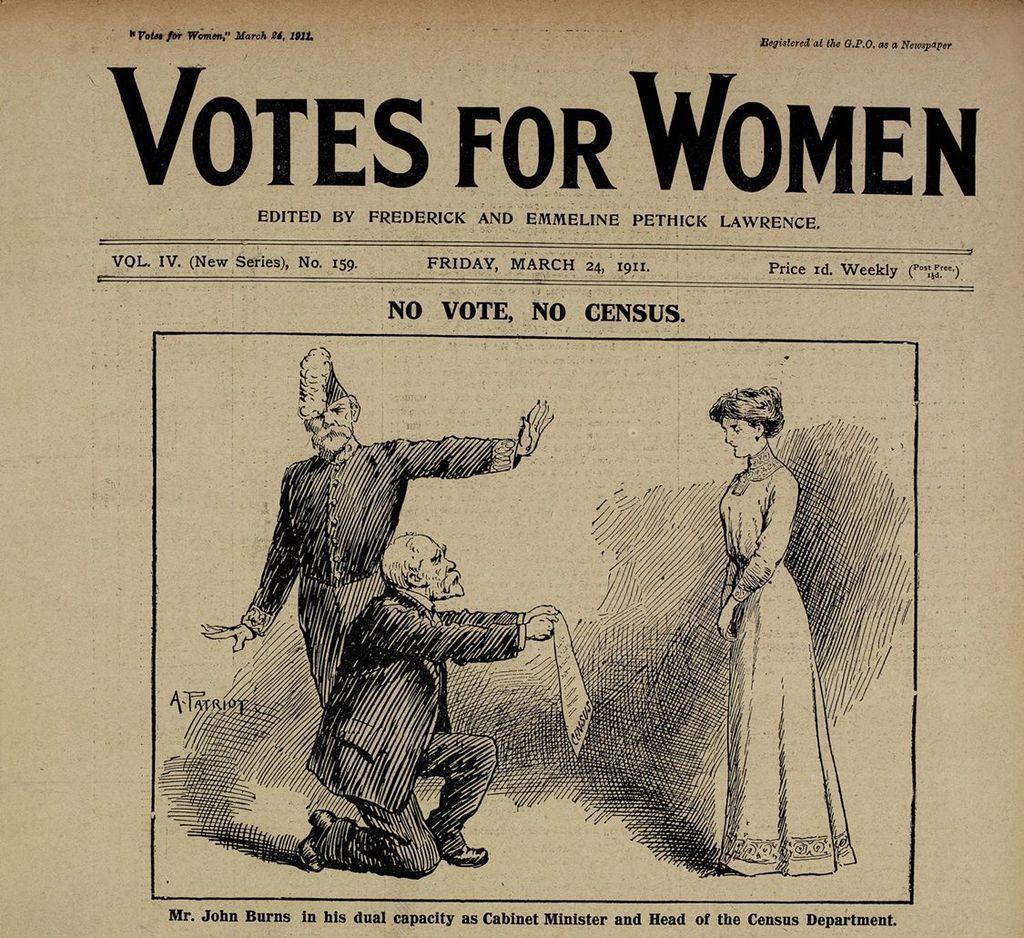Please provide a concise description of this image. This might be a poster, in this image in the center there is a drawing of two men and one woman and there is a text at the top and bottom of the image. 